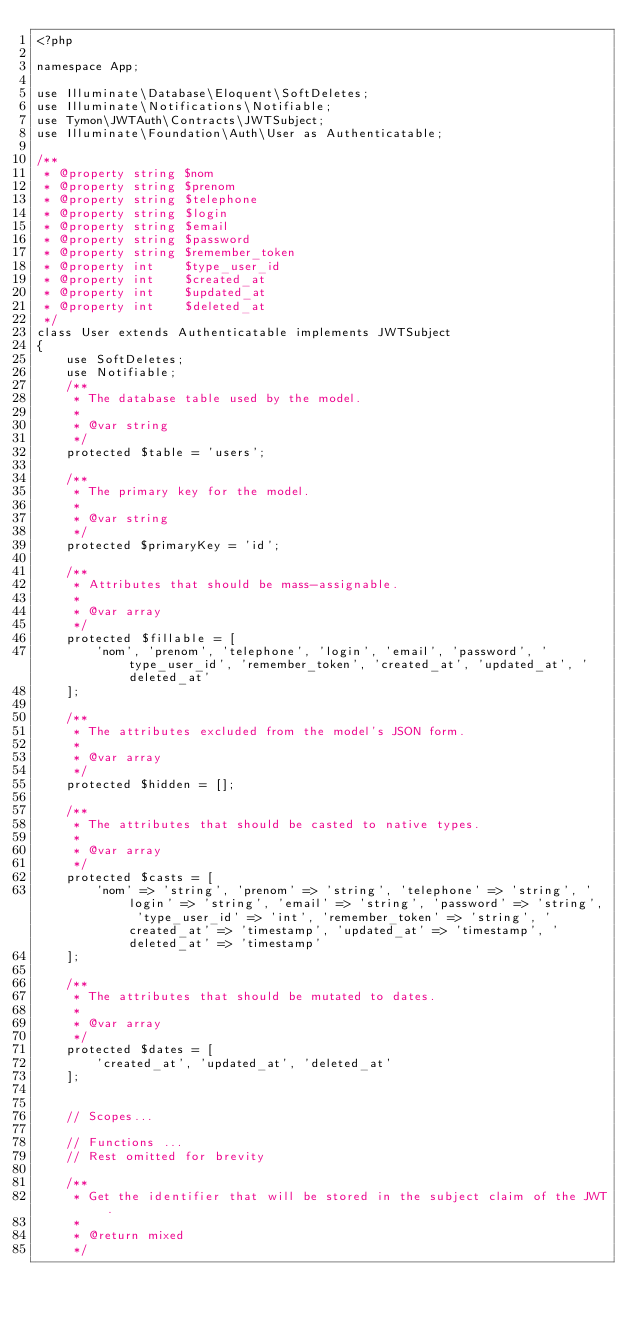Convert code to text. <code><loc_0><loc_0><loc_500><loc_500><_PHP_><?php

namespace App;

use Illuminate\Database\Eloquent\SoftDeletes;
use Illuminate\Notifications\Notifiable;
use Tymon\JWTAuth\Contracts\JWTSubject;
use Illuminate\Foundation\Auth\User as Authenticatable;

/**
 * @property string $nom
 * @property string $prenom
 * @property string $telephone
 * @property string $login
 * @property string $email
 * @property string $password
 * @property string $remember_token
 * @property int    $type_user_id
 * @property int    $created_at
 * @property int    $updated_at
 * @property int    $deleted_at
 */
class User extends Authenticatable implements JWTSubject
{
    use SoftDeletes;
    use Notifiable;
    /**
     * The database table used by the model.
     *
     * @var string
     */
    protected $table = 'users';

    /**
     * The primary key for the model.
     *
     * @var string
     */
    protected $primaryKey = 'id';

    /**
     * Attributes that should be mass-assignable.
     *
     * @var array
     */
    protected $fillable = [
        'nom', 'prenom', 'telephone', 'login', 'email', 'password', 'type_user_id', 'remember_token', 'created_at', 'updated_at', 'deleted_at'
    ];

    /**
     * The attributes excluded from the model's JSON form.
     *
     * @var array
     */
    protected $hidden = [];

    /**
     * The attributes that should be casted to native types.
     *
     * @var array
     */
    protected $casts = [
        'nom' => 'string', 'prenom' => 'string', 'telephone' => 'string', 'login' => 'string', 'email' => 'string', 'password' => 'string', 'type_user_id' => 'int', 'remember_token' => 'string', 'created_at' => 'timestamp', 'updated_at' => 'timestamp', 'deleted_at' => 'timestamp'
    ];

    /**
     * The attributes that should be mutated to dates.
     *
     * @var array
     */
    protected $dates = [
        'created_at', 'updated_at', 'deleted_at'
    ];


    // Scopes...

    // Functions ...
    // Rest omitted for brevity

    /**
     * Get the identifier that will be stored in the subject claim of the JWT.
     *
     * @return mixed
     */</code> 